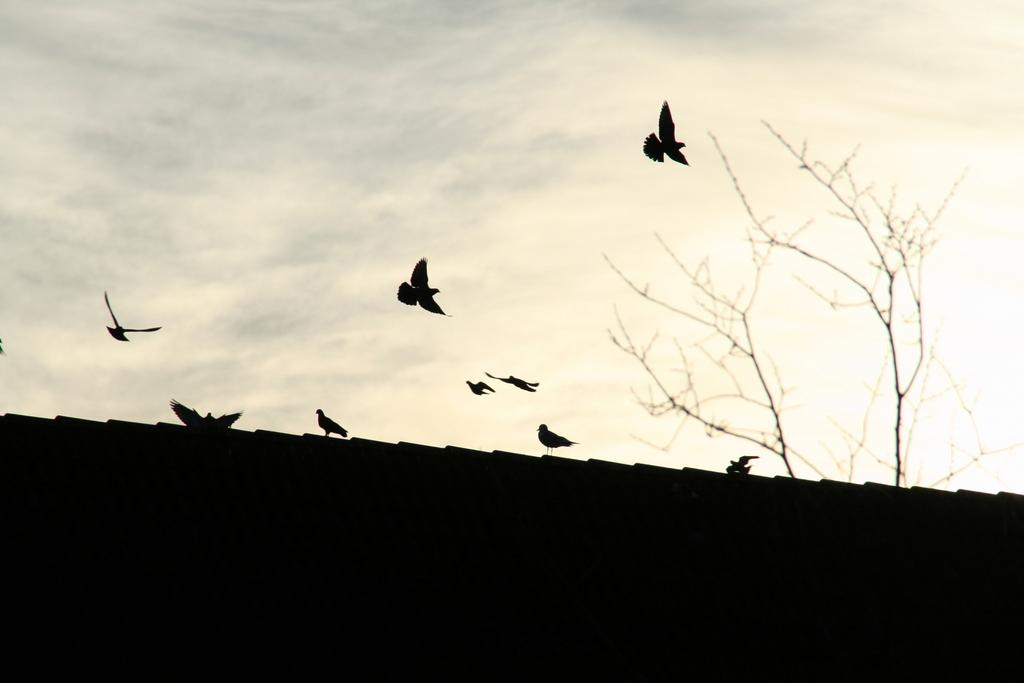What is the condition of the sky in the image? The sky is cloudy in the image. What type of animals can be seen in the image? Birds can be seen in the image. What is the appearance of the tree in the image? There is a bare tree in the image. What are some of the birds doing in the image? Some birds are flying in the image. What type of copper addition can be seen on the tree in the image? There is no copper addition present on the tree in the image. What type of waste is visible in the image? There is no waste visible in the image. 